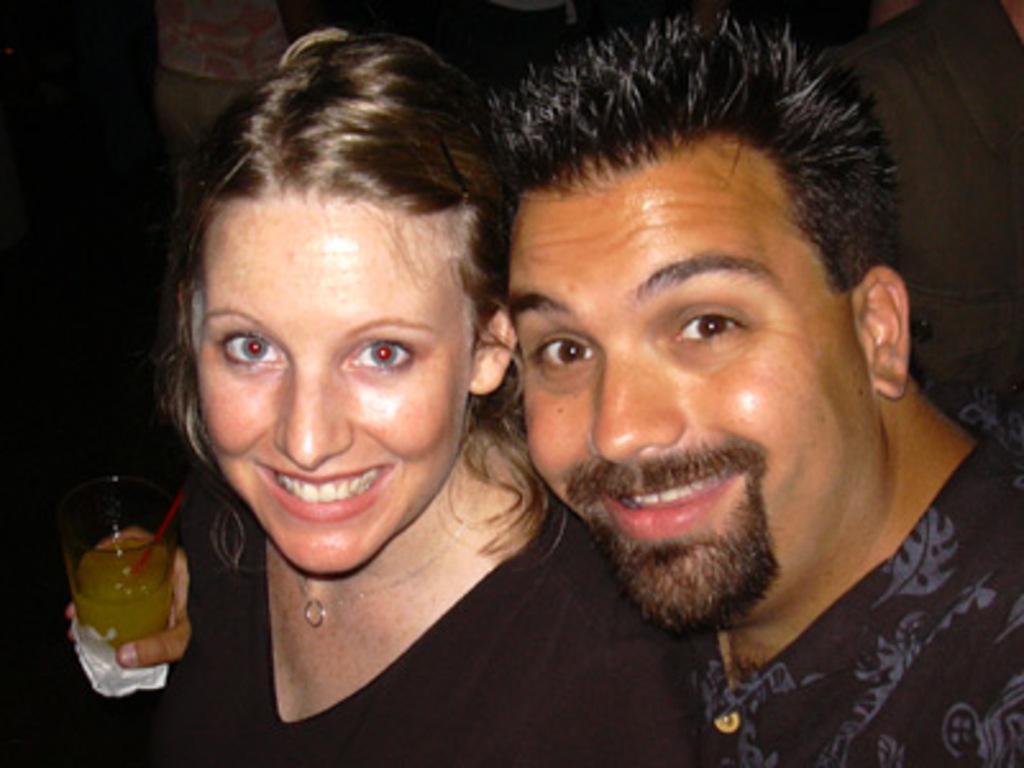Describe this image in one or two sentences. In this image I can see a man and a woman are smiling. Here I can see a glass. 